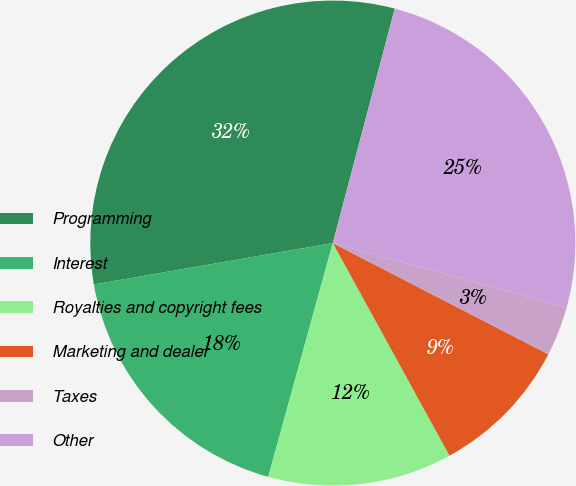Convert chart. <chart><loc_0><loc_0><loc_500><loc_500><pie_chart><fcel>Programming<fcel>Interest<fcel>Royalties and copyright fees<fcel>Marketing and dealer<fcel>Taxes<fcel>Other<nl><fcel>31.84%<fcel>17.98%<fcel>12.28%<fcel>9.43%<fcel>3.3%<fcel>25.17%<nl></chart> 